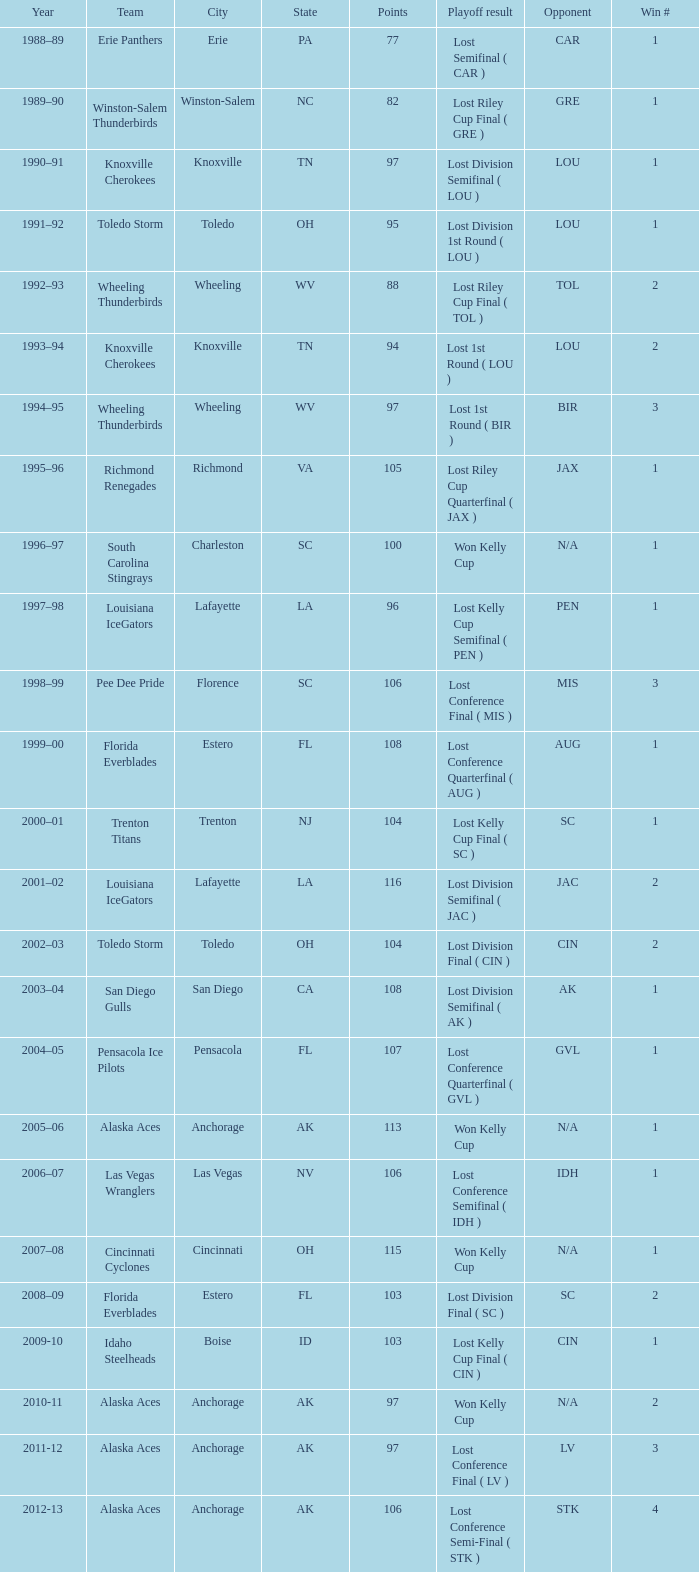What is the lowest Win #, when Year is "2011-12", and when Points is less than 97? None. 